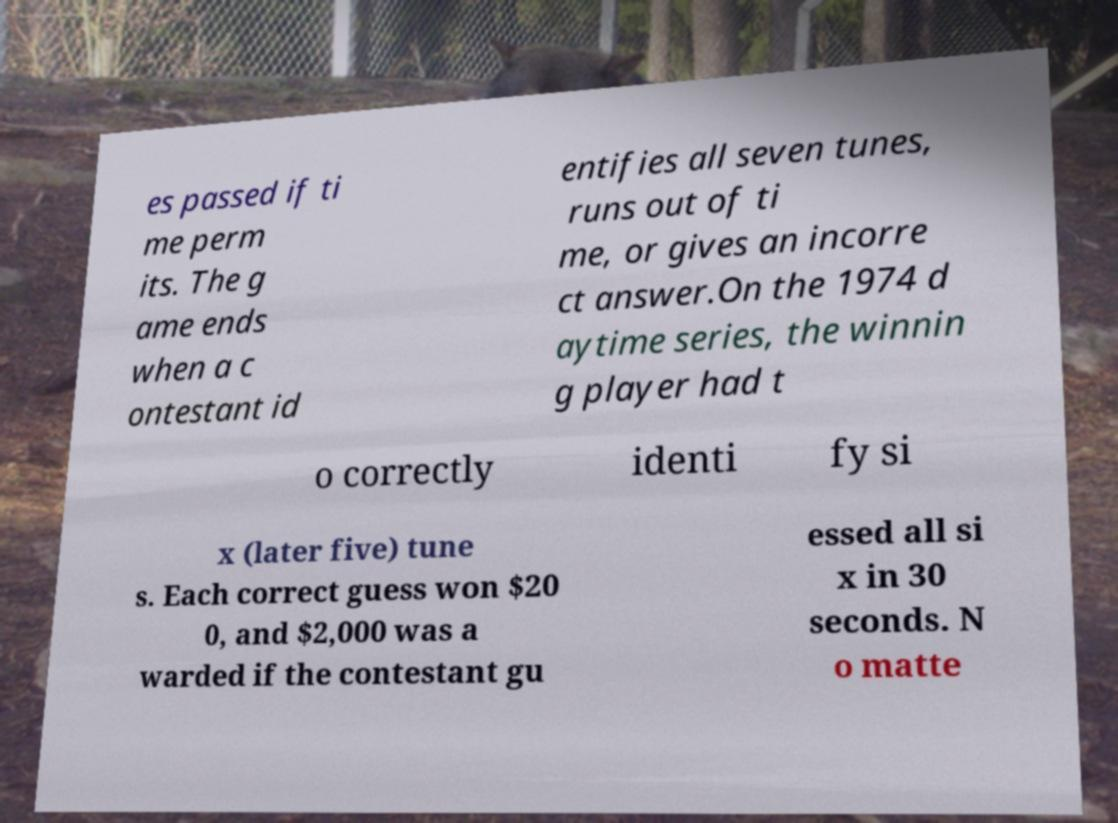Could you extract and type out the text from this image? es passed if ti me perm its. The g ame ends when a c ontestant id entifies all seven tunes, runs out of ti me, or gives an incorre ct answer.On the 1974 d aytime series, the winnin g player had t o correctly identi fy si x (later five) tune s. Each correct guess won $20 0, and $2,000 was a warded if the contestant gu essed all si x in 30 seconds. N o matte 